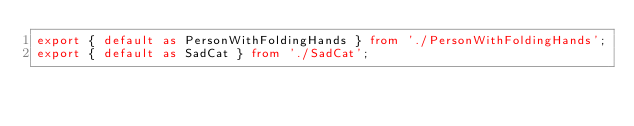<code> <loc_0><loc_0><loc_500><loc_500><_TypeScript_>export { default as PersonWithFoldingHands } from './PersonWithFoldingHands';
export { default as SadCat } from './SadCat';</code> 